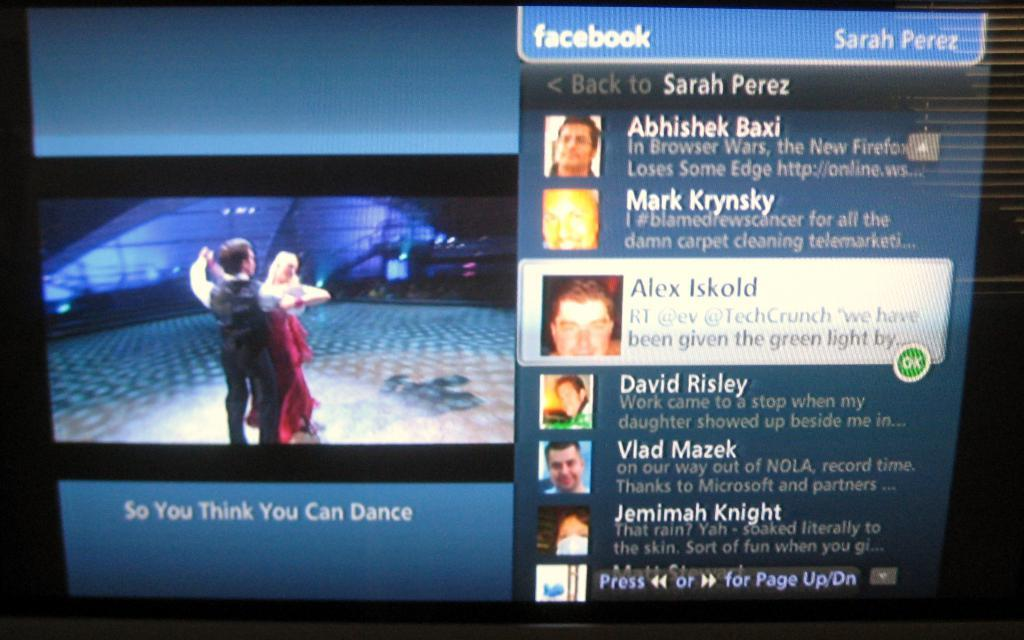What type of image is shown in the screenshot? There is a screenshot in the image, and it shows a couple dancing on the floor. What else can be seen in the image besides the screenshot? There is text visible in the image. What type of slope can be seen in the image? There is no slope present in the image; it features a screenshot of a couple dancing on the floor and text. What kind of apparel is the river wearing in the image? There is no river or apparel present in the image. 